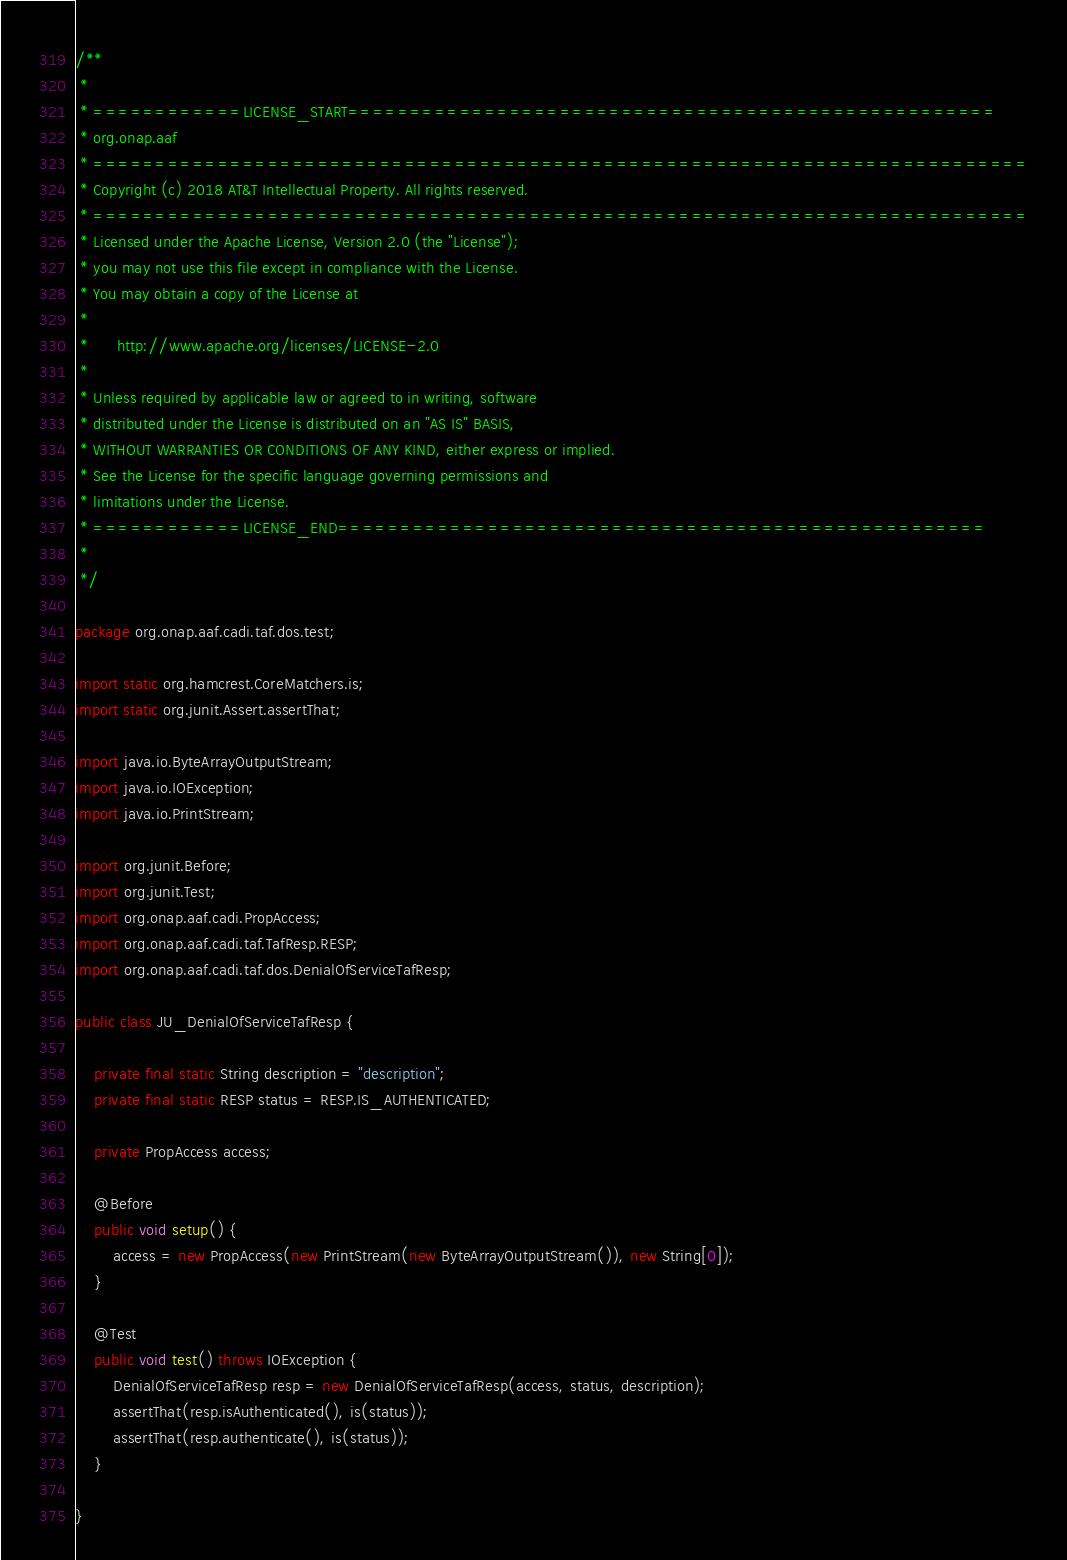<code> <loc_0><loc_0><loc_500><loc_500><_Java_>/**
 *
 * ============LICENSE_START====================================================
 * org.onap.aaf
 * ===========================================================================
 * Copyright (c) 2018 AT&T Intellectual Property. All rights reserved.
 * ===========================================================================
 * Licensed under the Apache License, Version 2.0 (the "License");
 * you may not use this file except in compliance with the License.
 * You may obtain a copy of the License at
 *
 *      http://www.apache.org/licenses/LICENSE-2.0
 *
 * Unless required by applicable law or agreed to in writing, software
 * distributed under the License is distributed on an "AS IS" BASIS,
 * WITHOUT WARRANTIES OR CONDITIONS OF ANY KIND, either express or implied.
 * See the License for the specific language governing permissions and
 * limitations under the License.
 * ============LICENSE_END====================================================
 *
 */

package org.onap.aaf.cadi.taf.dos.test;

import static org.hamcrest.CoreMatchers.is;
import static org.junit.Assert.assertThat;

import java.io.ByteArrayOutputStream;
import java.io.IOException;
import java.io.PrintStream;

import org.junit.Before;
import org.junit.Test;
import org.onap.aaf.cadi.PropAccess;
import org.onap.aaf.cadi.taf.TafResp.RESP;
import org.onap.aaf.cadi.taf.dos.DenialOfServiceTafResp;

public class JU_DenialOfServiceTafResp {

    private final static String description = "description";
    private final static RESP status = RESP.IS_AUTHENTICATED;

    private PropAccess access;

    @Before
    public void setup() {
        access = new PropAccess(new PrintStream(new ByteArrayOutputStream()), new String[0]);
    }

    @Test
    public void test() throws IOException {
        DenialOfServiceTafResp resp = new DenialOfServiceTafResp(access, status, description);
        assertThat(resp.isAuthenticated(), is(status));
        assertThat(resp.authenticate(), is(status));
    }

}
</code> 